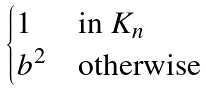Convert formula to latex. <formula><loc_0><loc_0><loc_500><loc_500>\begin{cases} 1 & \text {in } K _ { n } \\ b ^ { 2 } & \text {otherwise} \end{cases}</formula> 